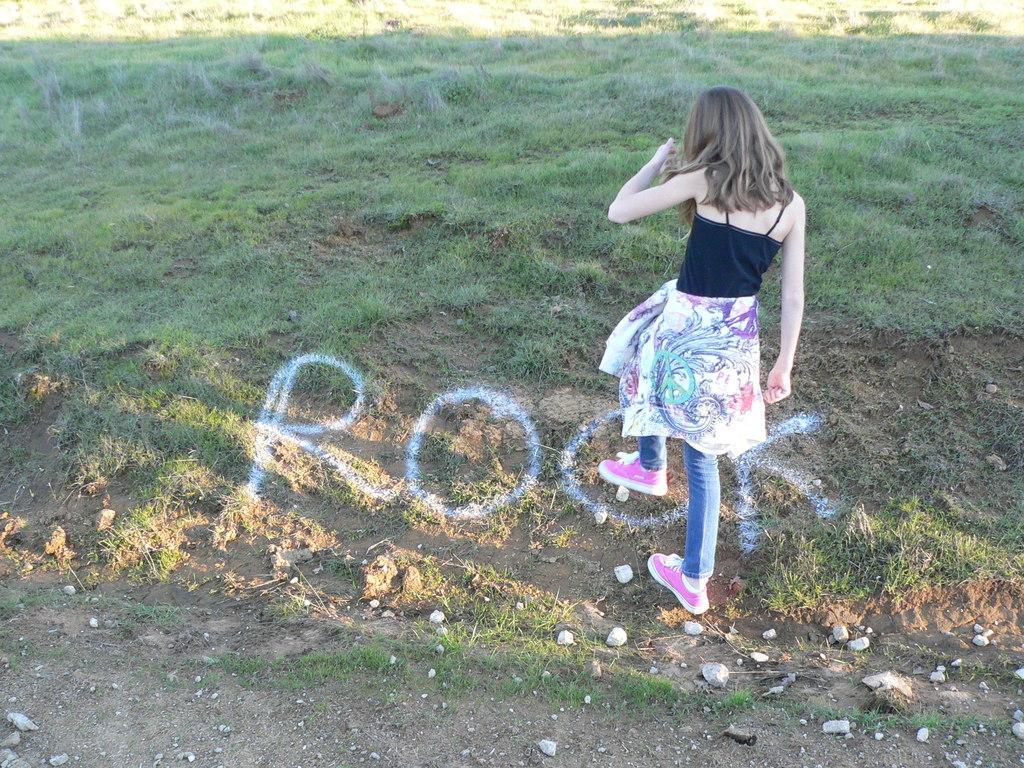Please provide a concise description of this image. There is a girl standing in the foreground with pink shoes, Blue jeans. There is some text at the bottom. There is grass at the background. 